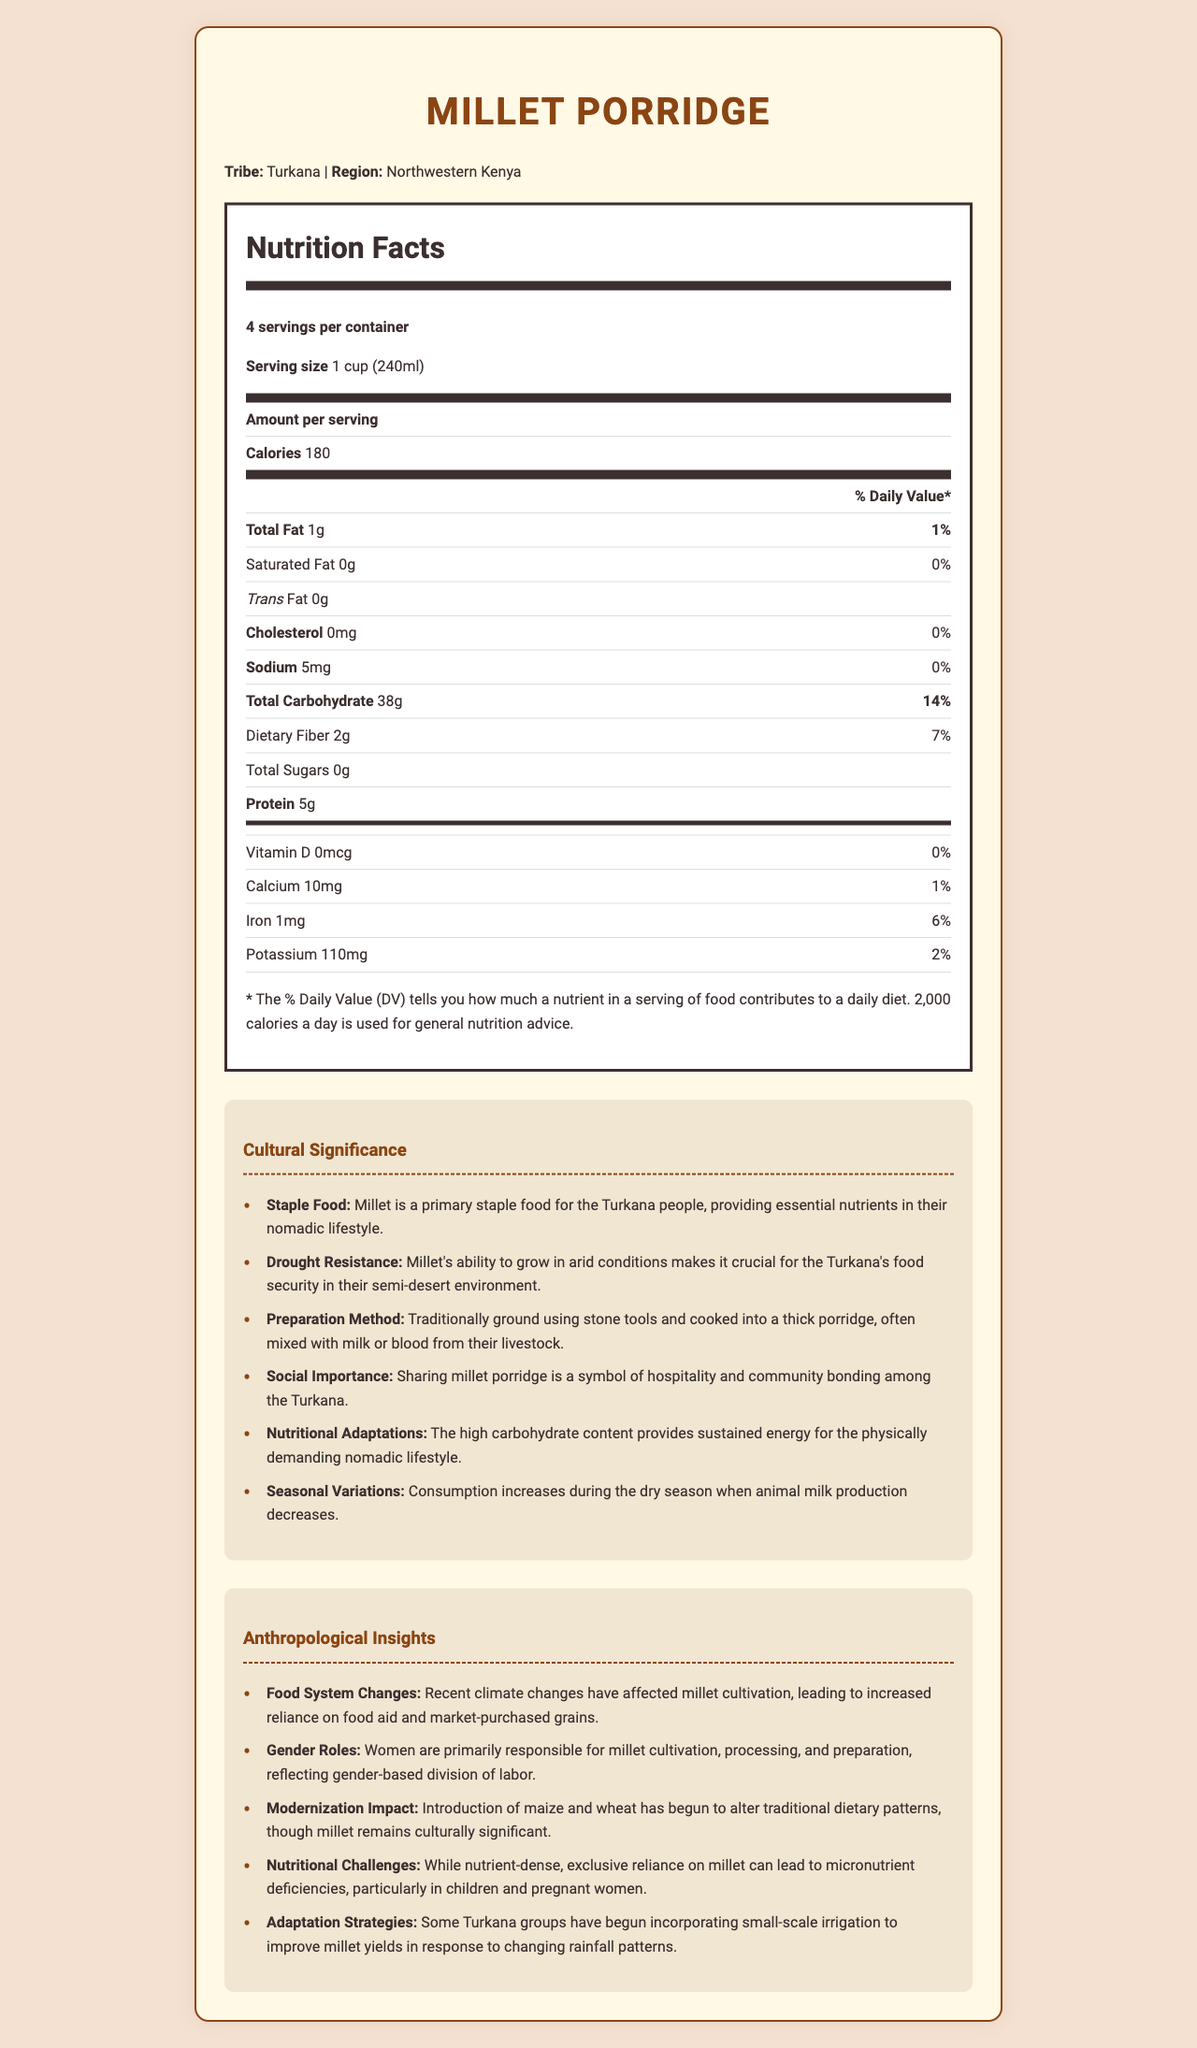what is the serving size of Millet Porridge? The serving size is listed at the beginning of the Nutrition Facts section as "1 cup (240ml)."
Answer: 1 cup (240ml) how many calories are in one serving of Millet Porridge? The number of calories per serving is given right after the amount per serving section.
Answer: 180 calories what percentage of the Daily Value is the total carbohydrate content? Under the Nutrition Facts, the total carbohydrate content is 38g, which equals 14% of the Daily Value.
Answer: 14% what is the primary role of millet in the Turkana tribe's diet? The document mentions that "Millet is a primary staple food for the Turkana people, providing essential nutrients in their nomadic lifestyle."
Answer: Provides essential nutrients how much protein is in one serving of Millet Porridge? The protein content per serving is listed as 5g under the Nutrition Facts section.
Answer: 5g what is the main reason millet is crucial for the Turkana's food security? A. High iron content B. Grows in arid conditions C. High protein content D. Low sodium content "Millet's ability to grow in arid conditions makes it crucial for the Turkana's food security in their semi-desert environment."
Answer: B which nutrient is completely absent in Millet Porridge? A. Vitamin D B. Calcium C. Iron D. Potassium According to the Nutrition Facts, Vitamin D has 0mcg, indicating it is absent.
Answer: A do the Turkana people use millet in their porridge preparation? Yes/No The document states that millet is traditionally ground using stone tools and cooked into a thick porridge, often mixed with milk or blood.
Answer: Yes what is the percentage of Daily Value for dietary fiber in a serving of Millet Porridge? The Daily Value percentage for dietary fiber is listed as 7%.
Answer: 7% how does the consumption of millet porridge change seasonally? The document mentions that the consumption of millet porridge increases during the dry season when animal milk production decreases.
Answer: Increases during the dry season how has climate change affected millet cultivation for the Turkana? Under anthropological insights, it is mentioned that climate changes have led to an increased reliance on food aid and market-purchased grains.
Answer: Increased reliance on food aid and market-purchased grains who is primarily responsible for the cultivation, processing, and preparation of millet in the Turkana tribe? The document indicates that women are primarily responsible, reflecting gender-based division of labor.
Answer: Women what challenges arise from exclusive reliance on millet in the Turkana tribe? The document notes that exclusive reliance on millet can lead to micronutrient deficiencies, particularly in children and pregnant women.
Answer: Micronutrient deficiencies how have some Turkana groups adapted to changing rainfall patterns? The document states that some Turkana groups have begun using small-scale irrigation to improve millet yields.
Answer: Incorporating small-scale irrigation summarize the main points of the document The document discusses nutritional information and the cultural and anthropological significance of millet porridge for the Turkana tribe, emphasizing its role in their diet, its preparation, and the challenges and adaptations faced due to environmental changes.
Answer: The document provides Nutrition Facts for Millet Porridge, highlighting calorie content, macronutrient, and micronutrient values. It also outlines the cultural significance of millet for the Turkana tribe, including its role as a staple food, preparation methods, and social importance. Anthropological insights discuss the impact of climate change, gender roles, modernization, nutritional challenges, and adaptation strategies within the Turkana community. what are the main health benefits of millet porridge mentioned in the document? The document provides nutritional information and cultural significance but does not explicitly list health benefits.
Answer: Cannot be determined 